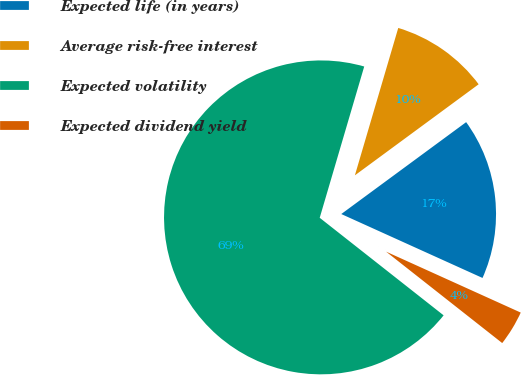<chart> <loc_0><loc_0><loc_500><loc_500><pie_chart><fcel>Expected life (in years)<fcel>Average risk-free interest<fcel>Expected volatility<fcel>Expected dividend yield<nl><fcel>16.86%<fcel>10.35%<fcel>68.94%<fcel>3.85%<nl></chart> 